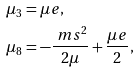Convert formula to latex. <formula><loc_0><loc_0><loc_500><loc_500>\mu _ { 3 } & = \mu e , \\ \mu _ { 8 } & = - \frac { \ m s ^ { 2 } } { 2 \mu } + \frac { \mu e } { 2 } ,</formula> 